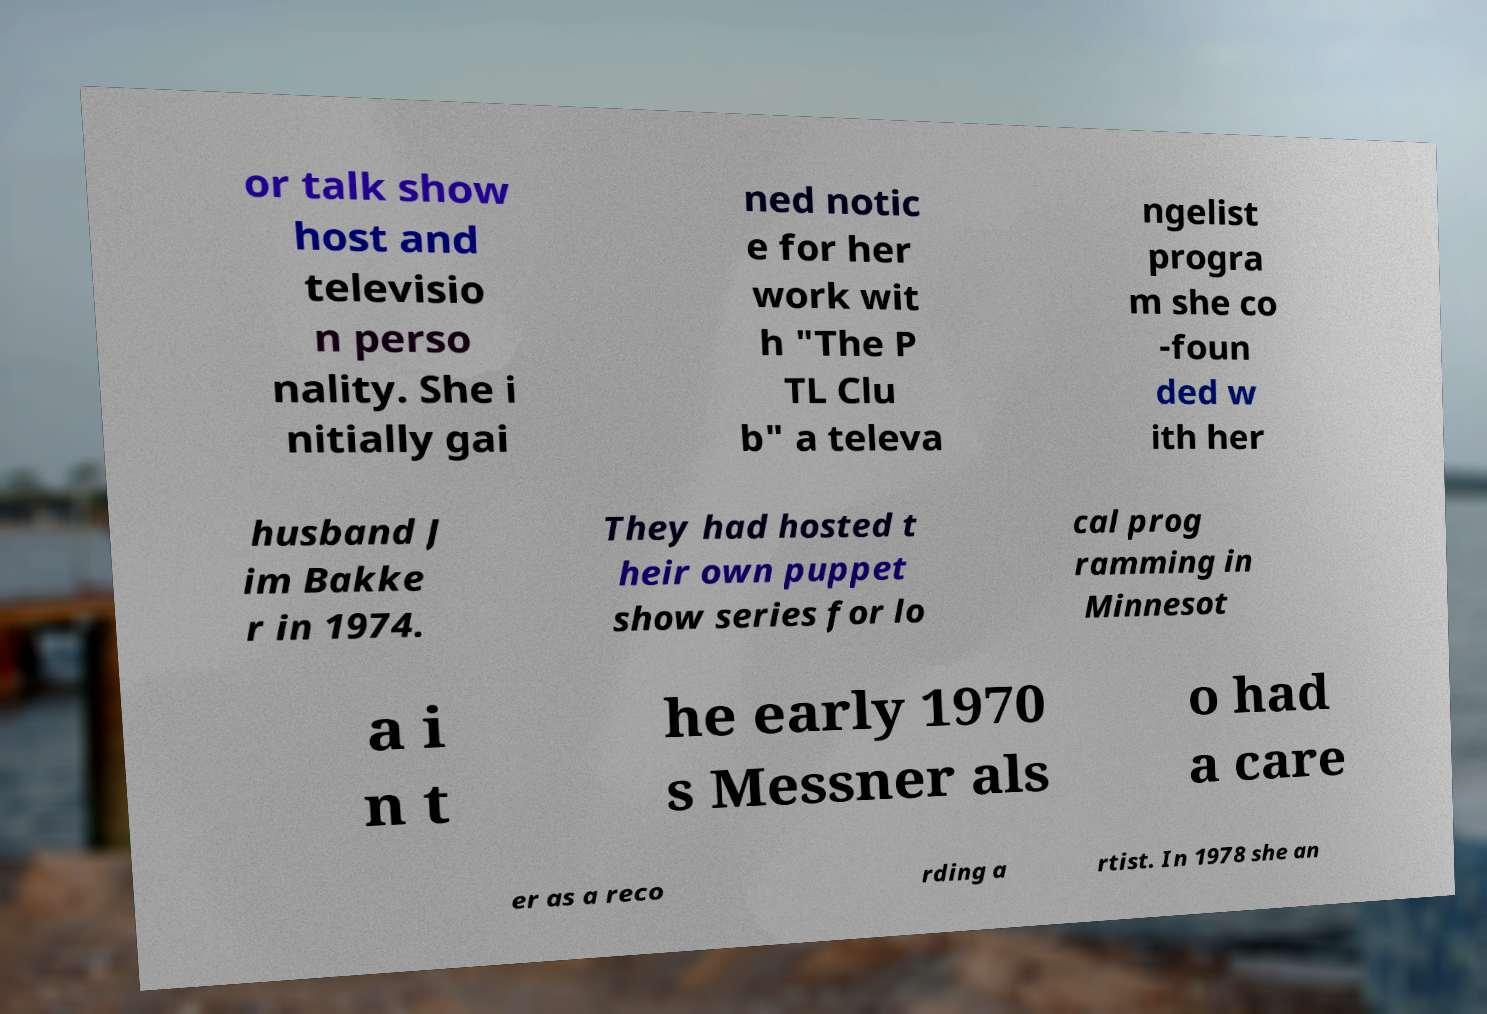What messages or text are displayed in this image? I need them in a readable, typed format. or talk show host and televisio n perso nality. She i nitially gai ned notic e for her work wit h "The P TL Clu b" a televa ngelist progra m she co -foun ded w ith her husband J im Bakke r in 1974. They had hosted t heir own puppet show series for lo cal prog ramming in Minnesot a i n t he early 1970 s Messner als o had a care er as a reco rding a rtist. In 1978 she an 